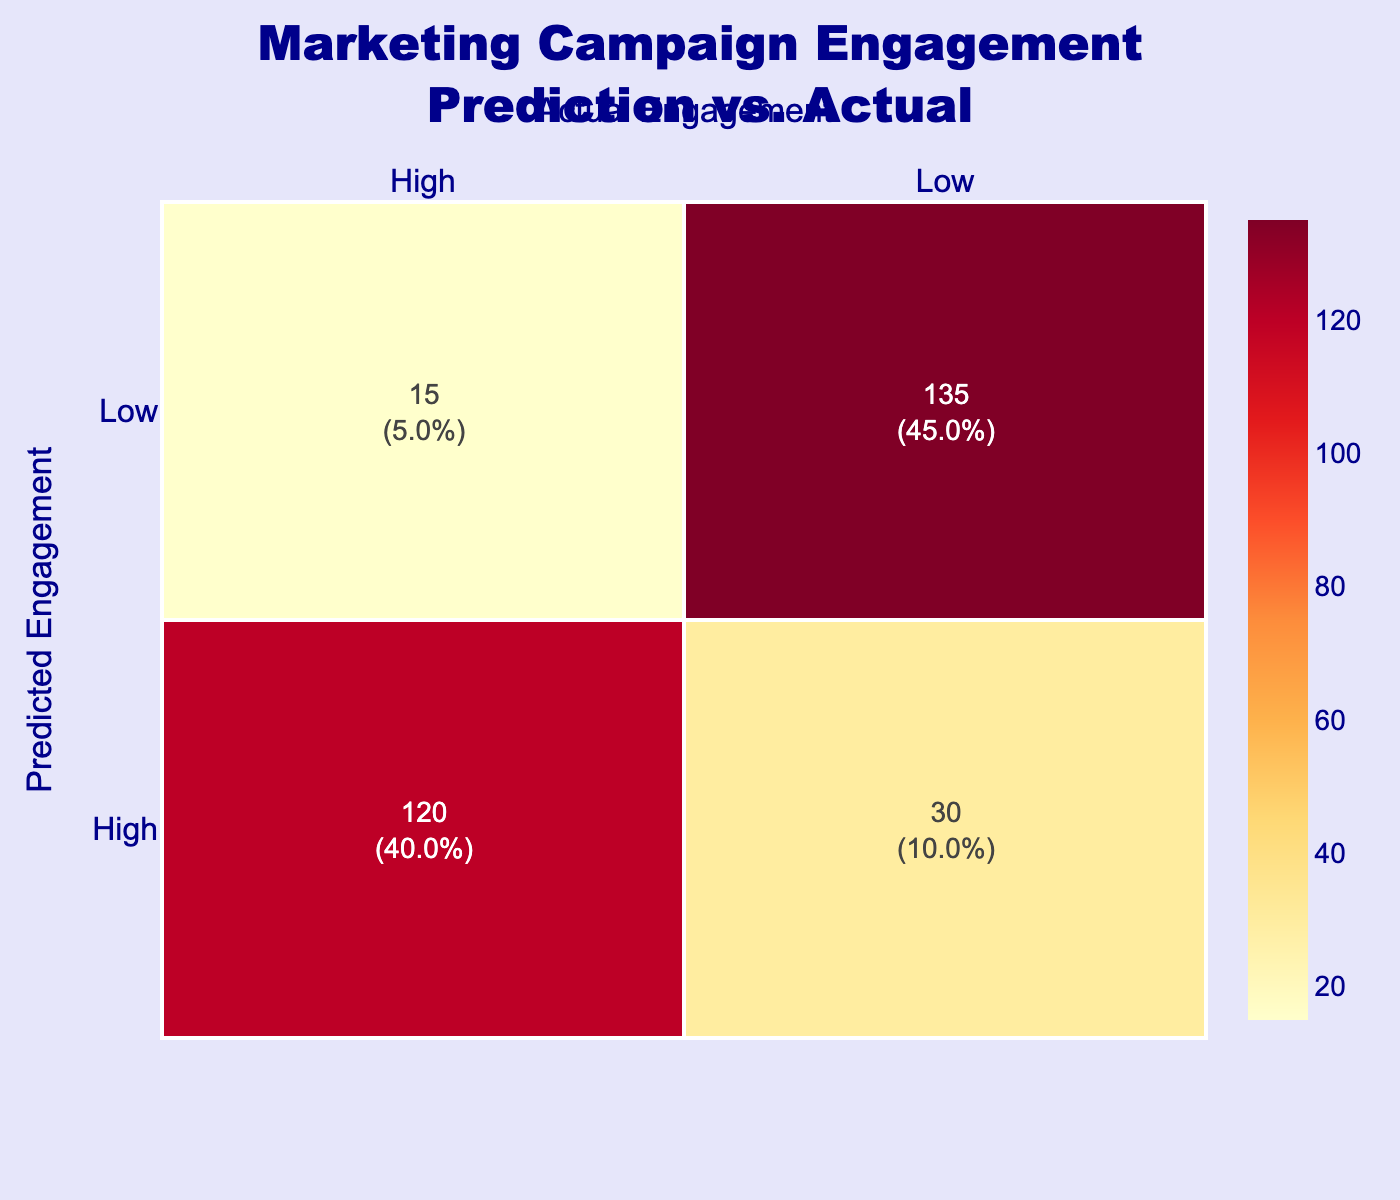What is the count of instances where the predicted engagement was high and the actual engagement was low? Referring to the confusion matrix, the count at the intersection of "High" predicted engagement and "Low" actual engagement is directly 30.
Answer: 30 What is the total count of high actual engagement instances? To find the total count of high actual engagement, we sum up the counts in the "High" column for actual engagement. This gives us 120 (High, High) + 15 (Low, High) = 135.
Answer: 135 What percentage of predicted high engagement resulted in actual high engagement? The confusion matrix indicates that there are 120 instances of predicted high engagement leading to actual high engagement. The total number of predictions for high engagement (120 + 30) is 150. To find the percentage, we calculate (120/150) * 100 = 80%.
Answer: 80% How many instances predict low engagement without falling into low actual engagement? There are 15 instances where predicted engagement is low and actual engagement is high. This is the only count in this category.
Answer: 15 Is it true that more than half of the actual engagements were low? The total count of actual low engagement instances is 30 (High, Low) + 135 (Low, Low) = 165. The total engagement instances are 30 + 120 + 15 + 135 = 300, thus half of 300 is 150. Since 165 is greater than 150, the answer is yes.
Answer: Yes What is the difference in counts between predicted high and low engagement that resulted in actual low engagement? The counts are 30 for predicted high engagement leading to low actual engagement and 135 for predicted low engagement leading to low actual engagement. The difference is 135 - 30 = 105.
Answer: 105 What is the average count of responses for high versus low predicted engagements? The average for high predicted engagement is (120 + 30) / 2 = 75, and for low predicted engagement, it is (15 + 135) / 2 = 75. So, the overall average count is (75 + 75) / 2 = 75.
Answer: 75 What is the total count of low predicted engagement instances? The low predicted engagement instances are 15 (Low, High) and 135 (Low, Low), so we sum them up: 15 + 135 = 150.
Answer: 150 How many instances had predicted low engagement that resulted in high engagement? The count displayed in the confusion matrix for predicted low engagement leading to high engagement is 15.
Answer: 15 